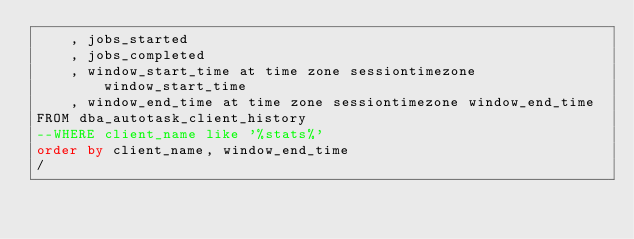Convert code to text. <code><loc_0><loc_0><loc_500><loc_500><_SQL_>	, jobs_started
	, jobs_completed
	, window_start_time at time zone sessiontimezone window_start_time
	, window_end_time at time zone sessiontimezone window_end_time
FROM dba_autotask_client_history
--WHERE client_name like '%stats%'
order by client_name, window_end_time
/
</code> 